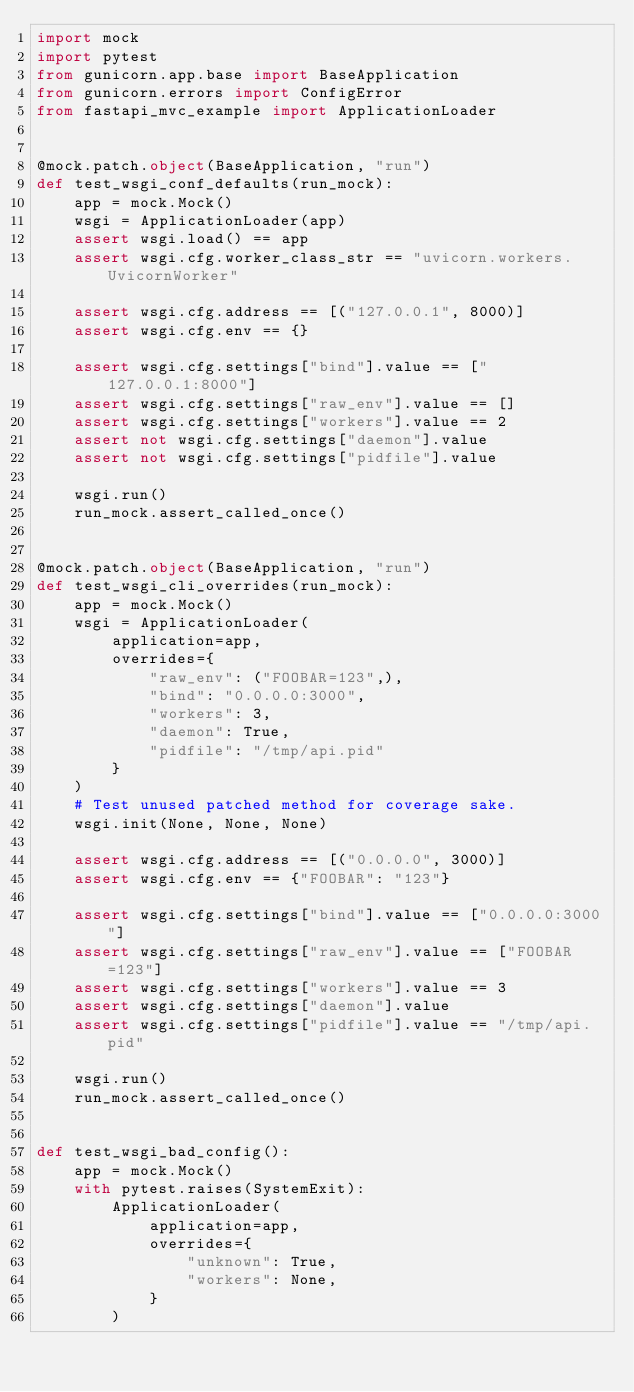Convert code to text. <code><loc_0><loc_0><loc_500><loc_500><_Python_>import mock
import pytest
from gunicorn.app.base import BaseApplication
from gunicorn.errors import ConfigError
from fastapi_mvc_example import ApplicationLoader


@mock.patch.object(BaseApplication, "run")
def test_wsgi_conf_defaults(run_mock):
    app = mock.Mock()
    wsgi = ApplicationLoader(app)
    assert wsgi.load() == app
    assert wsgi.cfg.worker_class_str == "uvicorn.workers.UvicornWorker"

    assert wsgi.cfg.address == [("127.0.0.1", 8000)]
    assert wsgi.cfg.env == {}

    assert wsgi.cfg.settings["bind"].value == ["127.0.0.1:8000"]
    assert wsgi.cfg.settings["raw_env"].value == []
    assert wsgi.cfg.settings["workers"].value == 2
    assert not wsgi.cfg.settings["daemon"].value
    assert not wsgi.cfg.settings["pidfile"].value

    wsgi.run()
    run_mock.assert_called_once()


@mock.patch.object(BaseApplication, "run")
def test_wsgi_cli_overrides(run_mock):
    app = mock.Mock()
    wsgi = ApplicationLoader(
        application=app,
        overrides={
            "raw_env": ("FOOBAR=123",),
            "bind": "0.0.0.0:3000",
            "workers": 3,
            "daemon": True,
            "pidfile": "/tmp/api.pid"
        }
    )
    # Test unused patched method for coverage sake.
    wsgi.init(None, None, None)

    assert wsgi.cfg.address == [("0.0.0.0", 3000)]
    assert wsgi.cfg.env == {"FOOBAR": "123"}

    assert wsgi.cfg.settings["bind"].value == ["0.0.0.0:3000"]
    assert wsgi.cfg.settings["raw_env"].value == ["FOOBAR=123"]
    assert wsgi.cfg.settings["workers"].value == 3
    assert wsgi.cfg.settings["daemon"].value
    assert wsgi.cfg.settings["pidfile"].value == "/tmp/api.pid"

    wsgi.run()
    run_mock.assert_called_once()


def test_wsgi_bad_config():
    app = mock.Mock()
    with pytest.raises(SystemExit):
        ApplicationLoader(
            application=app,
            overrides={
                "unknown": True,
                "workers": None,
            }
        )
</code> 